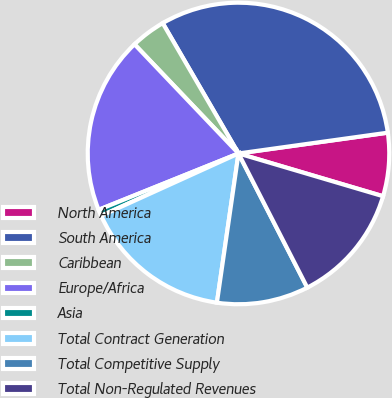Convert chart to OTSL. <chart><loc_0><loc_0><loc_500><loc_500><pie_chart><fcel>North America<fcel>South America<fcel>Caribbean<fcel>Europe/Africa<fcel>Asia<fcel>Total Contract Generation<fcel>Total Competitive Supply<fcel>Total Non-Regulated Revenues<nl><fcel>6.78%<fcel>31.18%<fcel>3.73%<fcel>18.98%<fcel>0.69%<fcel>15.93%<fcel>9.83%<fcel>12.88%<nl></chart> 